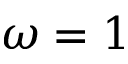<formula> <loc_0><loc_0><loc_500><loc_500>\omega = 1</formula> 